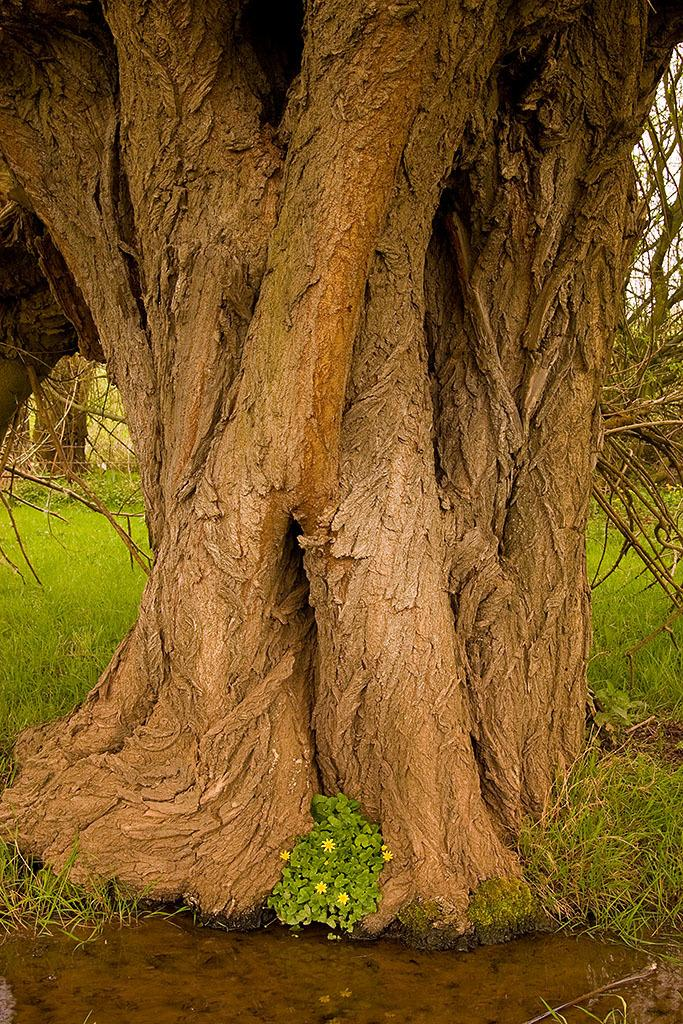What is the main object in the image? There is a tree trunk in the image. What type of vegetation is visible on the ground? There is grass and small plants on the ground in the image. What type of quiver can be seen hanging from the tree trunk in the image? There is no quiver present in the image; it only features a tree trunk, grass, and small plants. 